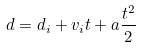<formula> <loc_0><loc_0><loc_500><loc_500>d = d _ { i } + v _ { i } t + a \frac { t ^ { 2 } } { 2 }</formula> 